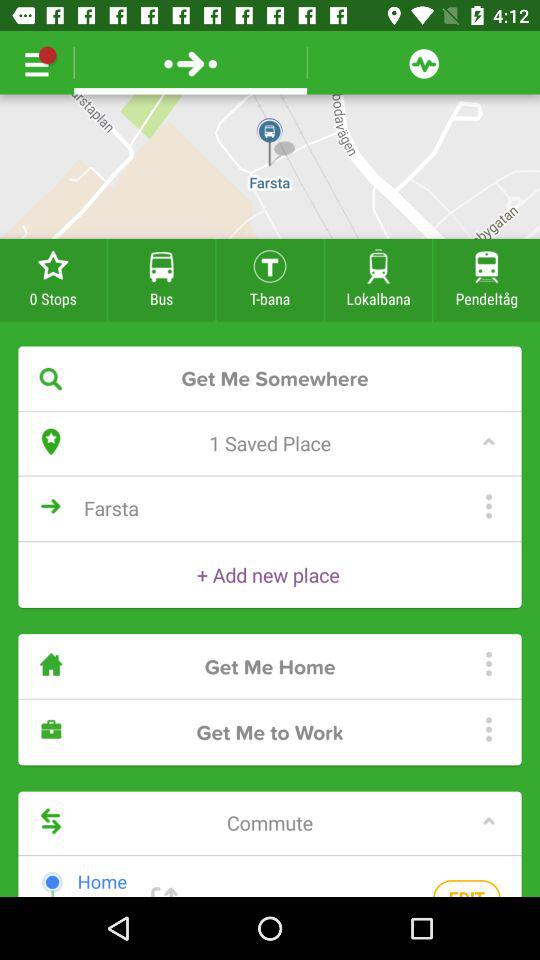What is the number of saved places? The number of saved places is 1. 